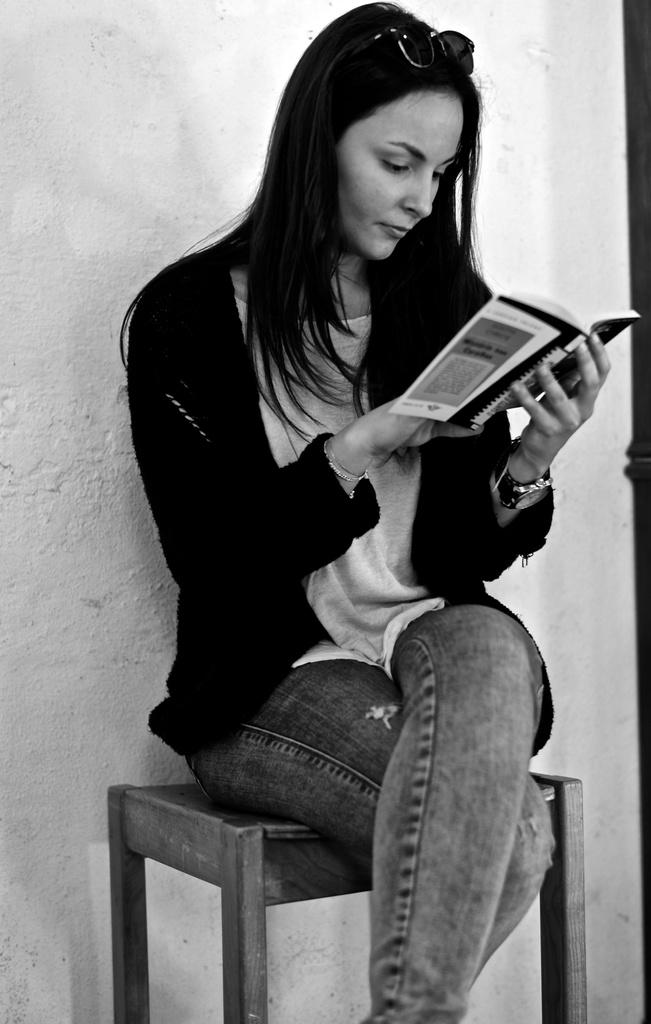Who is the main subject in the image? There is a woman in the image. What is the woman doing in the image? The woman is sitting on a stool and reading a book. What is the woman wearing that is unusual for reading? The woman is wearing goggles. What can be seen in the background of the image? There is a wall in the background of the image. What type of growth can be seen on the prison wall in the image? There is no prison or growth present in the image; it features a woman sitting on a stool and reading a book with a wall in the background. What shape is the circle that the woman is drawing in the image? There is no circle or drawing activity present in the image. 